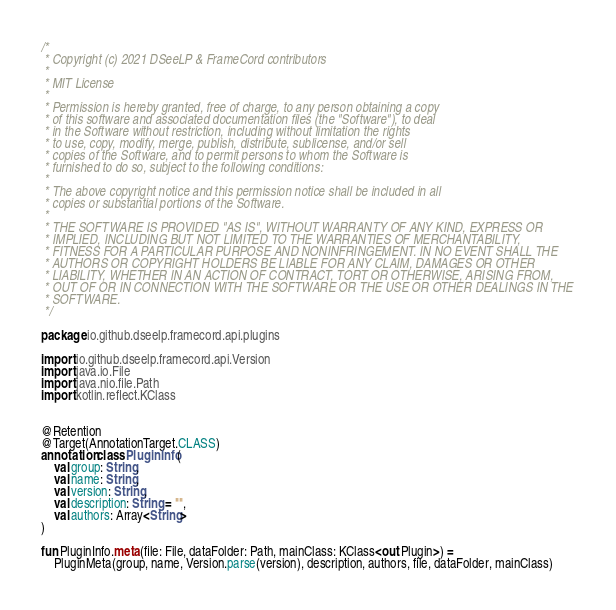Convert code to text. <code><loc_0><loc_0><loc_500><loc_500><_Kotlin_>/*
 * Copyright (c) 2021 DSeeLP & FrameCord contributors
 *
 * MIT License
 *
 * Permission is hereby granted, free of charge, to any person obtaining a copy
 * of this software and associated documentation files (the "Software"), to deal
 * in the Software without restriction, including without limitation the rights
 * to use, copy, modify, merge, publish, distribute, sublicense, and/or sell
 * copies of the Software, and to permit persons to whom the Software is
 * furnished to do so, subject to the following conditions:
 *
 * The above copyright notice and this permission notice shall be included in all
 * copies or substantial portions of the Software.
 *
 * THE SOFTWARE IS PROVIDED "AS IS", WITHOUT WARRANTY OF ANY KIND, EXPRESS OR
 * IMPLIED, INCLUDING BUT NOT LIMITED TO THE WARRANTIES OF MERCHANTABILITY,
 * FITNESS FOR A PARTICULAR PURPOSE AND NONINFRINGEMENT. IN NO EVENT SHALL THE
 * AUTHORS OR COPYRIGHT HOLDERS BE LIABLE FOR ANY CLAIM, DAMAGES OR OTHER
 * LIABILITY, WHETHER IN AN ACTION OF CONTRACT, TORT OR OTHERWISE, ARISING FROM,
 * OUT OF OR IN CONNECTION WITH THE SOFTWARE OR THE USE OR OTHER DEALINGS IN THE
 * SOFTWARE.
 */

package io.github.dseelp.framecord.api.plugins

import io.github.dseelp.framecord.api.Version
import java.io.File
import java.nio.file.Path
import kotlin.reflect.KClass


@Retention
@Target(AnnotationTarget.CLASS)
annotation class PluginInfo(
    val group: String,
    val name: String,
    val version: String,
    val description: String = "",
    val authors: Array<String>
)

fun PluginInfo.meta(file: File, dataFolder: Path, mainClass: KClass<out Plugin>) =
    PluginMeta(group, name, Version.parse(version), description, authors, file, dataFolder, mainClass)
</code> 